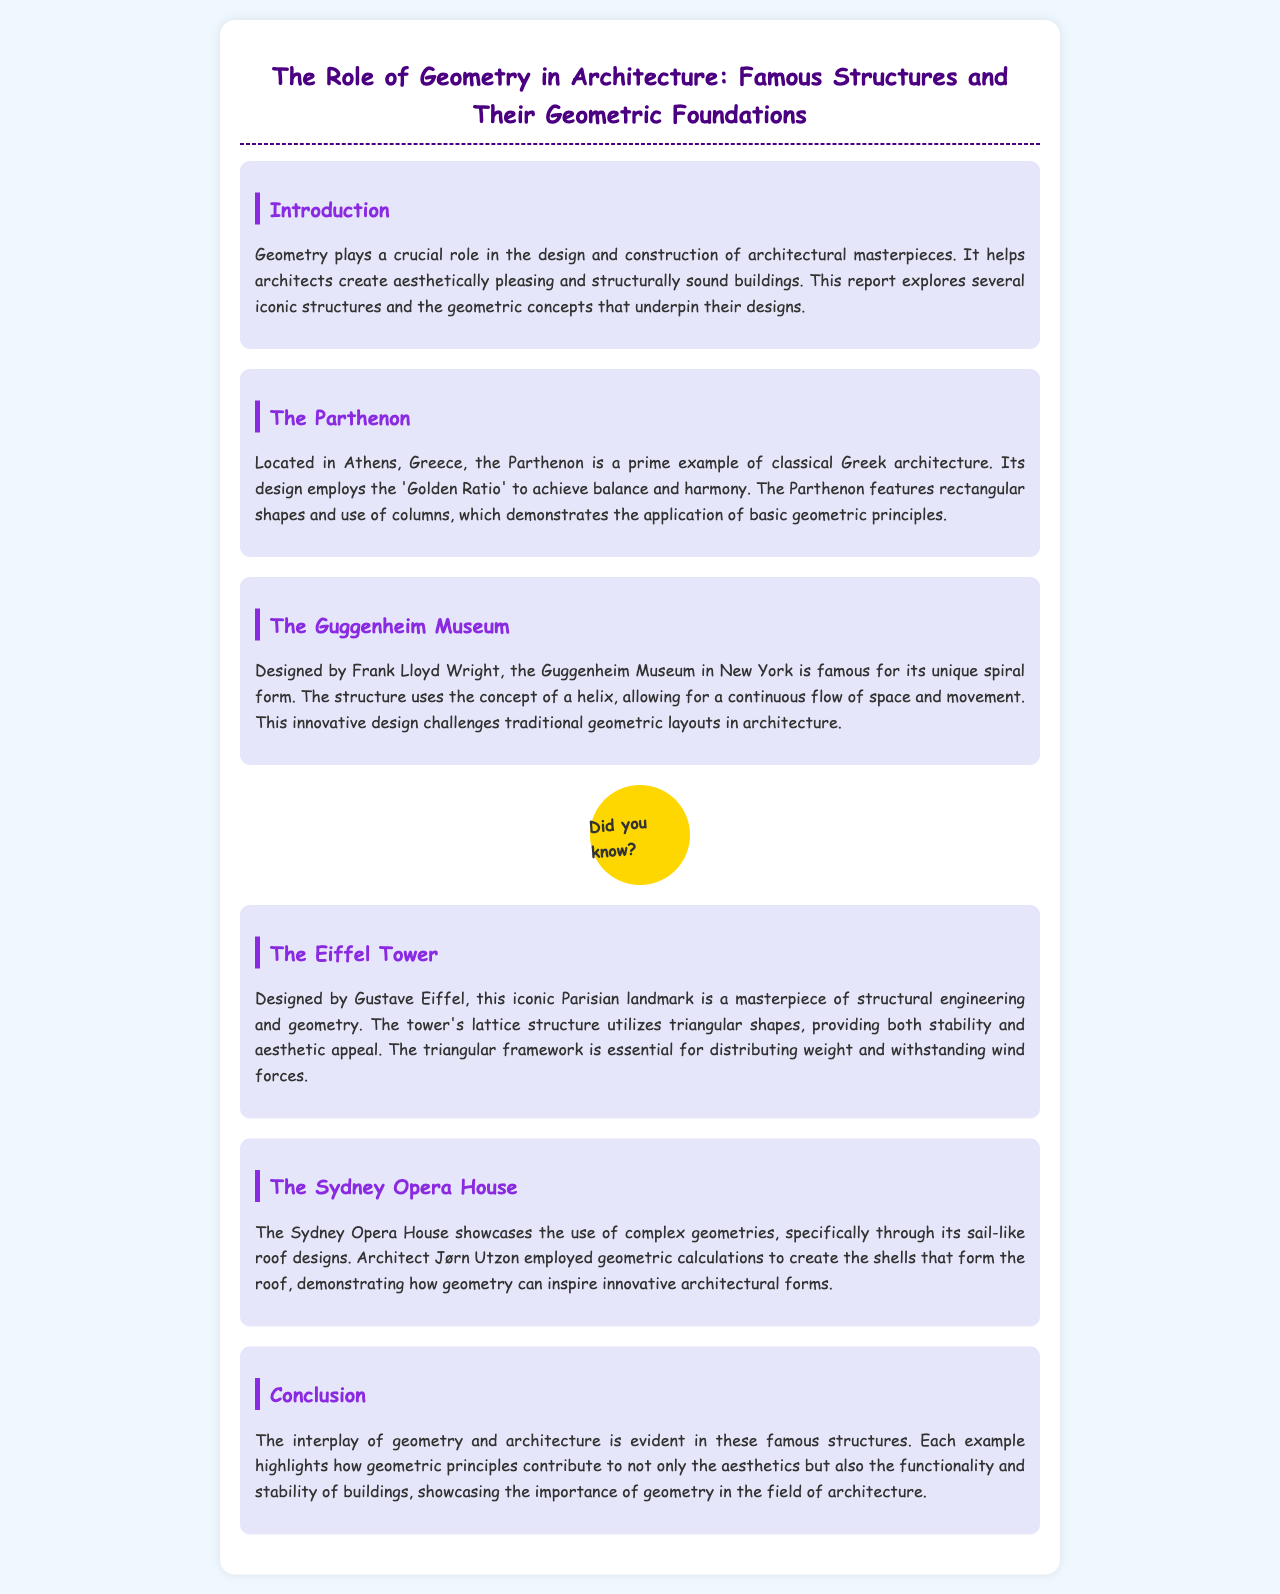What is the primary role of geometry in architecture? The primary role of geometry in architecture is to help create aesthetically pleasing and structurally sound buildings.
Answer: Aesthetics and structure Where is the Parthenon located? The location of the Parthenon is mentioned in the document.
Answer: Athens, Greece Who designed the Guggenheim Museum? The designer of the Guggenheim Museum is specified in the report.
Answer: Frank Lloyd Wright What geometric concept is prominently used in the Eiffel Tower's structure? The document mentions a specific geometric concept related to the Eiffel Tower.
Answer: Triangular shapes What is the unique architectural feature of the Sydney Opera House? The report describes an innovative characteristic of the Sydney Opera House.
Answer: Sail-like roof designs Which famous structure uses the 'Golden Ratio' in its design? The document points out a structure that employs the Golden Ratio.
Answer: The Parthenon How does the Guggenheim Museum challenge traditional geometric layouts? It discusses how the Guggenheim Museum's design differs from traditional layouts.
Answer: Spiral form What contributes to the stability of the Eiffel Tower? The document explains a structural aspect contributing to the Eiffel Tower's stability.
Answer: Triangular framework What is the overarching theme of the report? The overall theme is summarized in the conclusion section of the document.
Answer: Interplay of geometry and architecture 